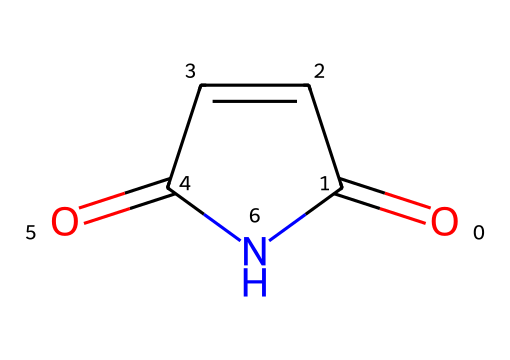What is the name of this chemical? The chemical represented by the SMILES code O=C1C=CC(=O)N1 is commonly known as maleimide.
Answer: maleimide How many carbon atoms are in maleimide? Analyzing the SMILES, we see there are four carbon atoms present in the structure.
Answer: 4 How many nitrogen atoms are in maleimide? The structure contains one nitrogen atom, as denoted by the 'N' in the SMILES notation.
Answer: 1 What type of chemical is maleimide? Maleimide belongs to the class of compounds known as imides, characterized by the structure containing a carbonyl adjacent to a nitrogen.
Answer: imide What functional groups are present in maleimide? Maleimide contains both a carbonyl group (C=O) and an imide group, derived from the reaction between a dicarboxylic acid and ammonia.
Answer: carbonyl, imide Why is maleimide utilized in biodegradable materials? Maleimide can react with various substrates and form crosslinks, giving it properties suitable for biodegradable materials which are enhanced by its ability to form stable structures.
Answer: crosslinking properties 